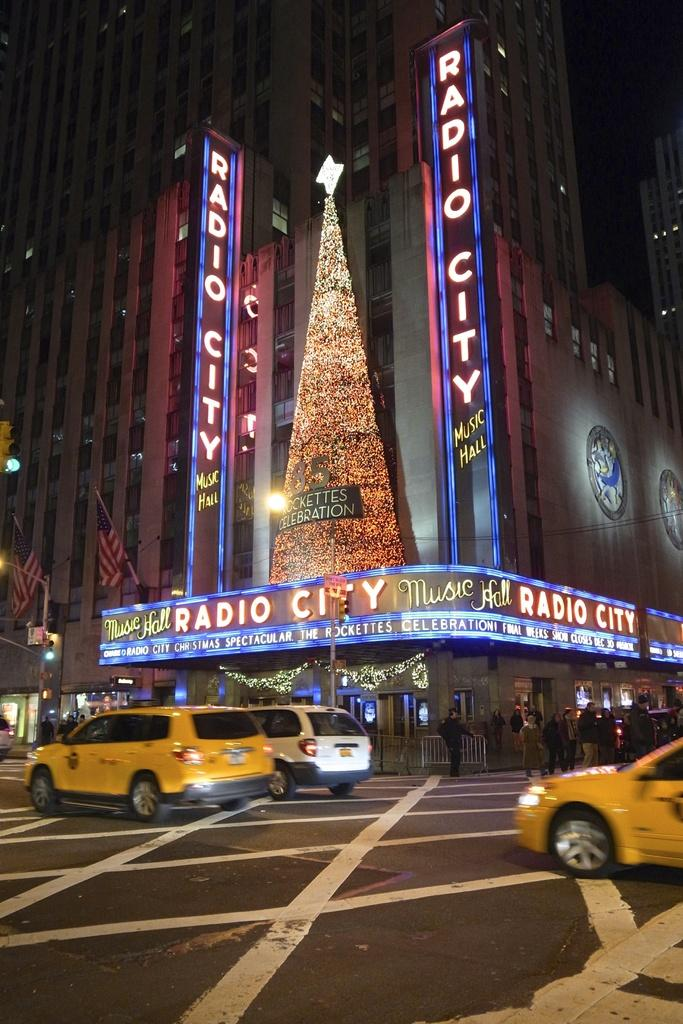<image>
Present a compact description of the photo's key features. a Radio City sign that is above the street 